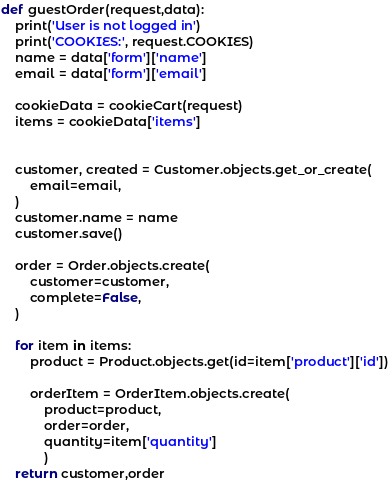<code> <loc_0><loc_0><loc_500><loc_500><_Python_>
def guestOrder(request,data):
    print('User is not logged in')
    print('COOKIES:', request.COOKIES)
    name = data['form']['name']
    email = data['form']['email']

    cookieData = cookieCart(request)
    items = cookieData['items']


    customer, created = Customer.objects.get_or_create(
        email=email,
    )
    customer.name = name
    customer.save()

    order = Order.objects.create(
        customer=customer,
        complete=False,
    )

    for item in items:
        product = Product.objects.get(id=item['product']['id'])

        orderItem = OrderItem.objects.create(
            product=product,
            order=order,
            quantity=item['quantity']
            )
    return customer,order

</code> 